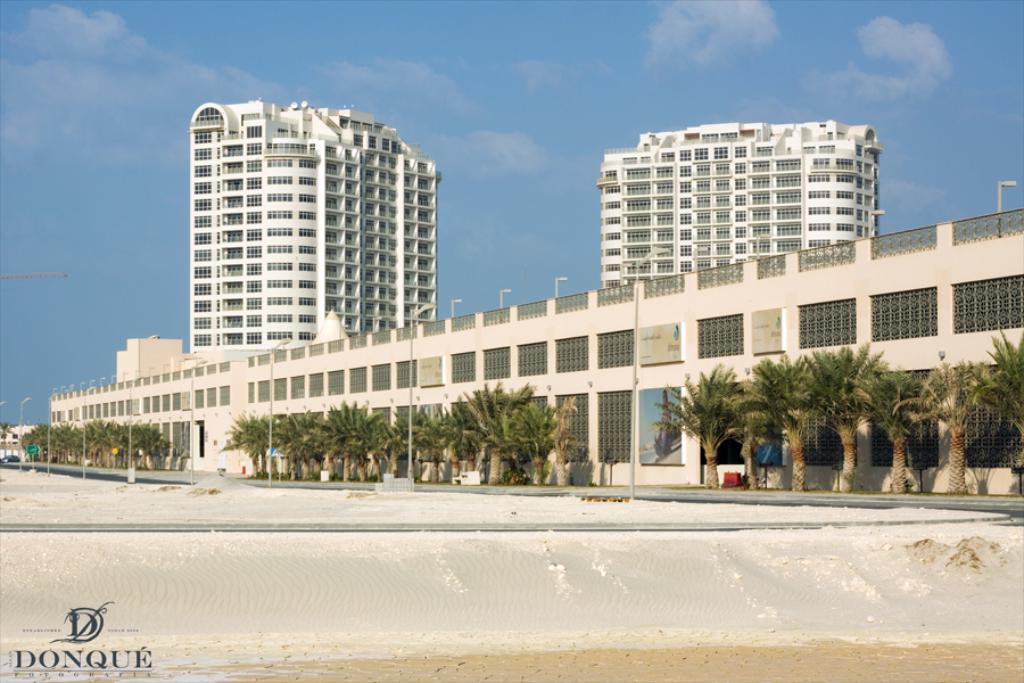What type of structures can be seen in the background of the image? There are buildings in the background of the image. What is located in front of the buildings? Trees are present in front of the buildings. What type of lighting is visible in the image? Street lights are visible in the image. What is visible at the top of the image? The sky is visible in the image. What can be seen in the sky? Clouds are present in the sky. Can you see a toy on top of the hill in the image? There is no hill or toy present in the image. What type of cable is connecting the buildings in the image? There is no cable connecting the buildings in the image. 